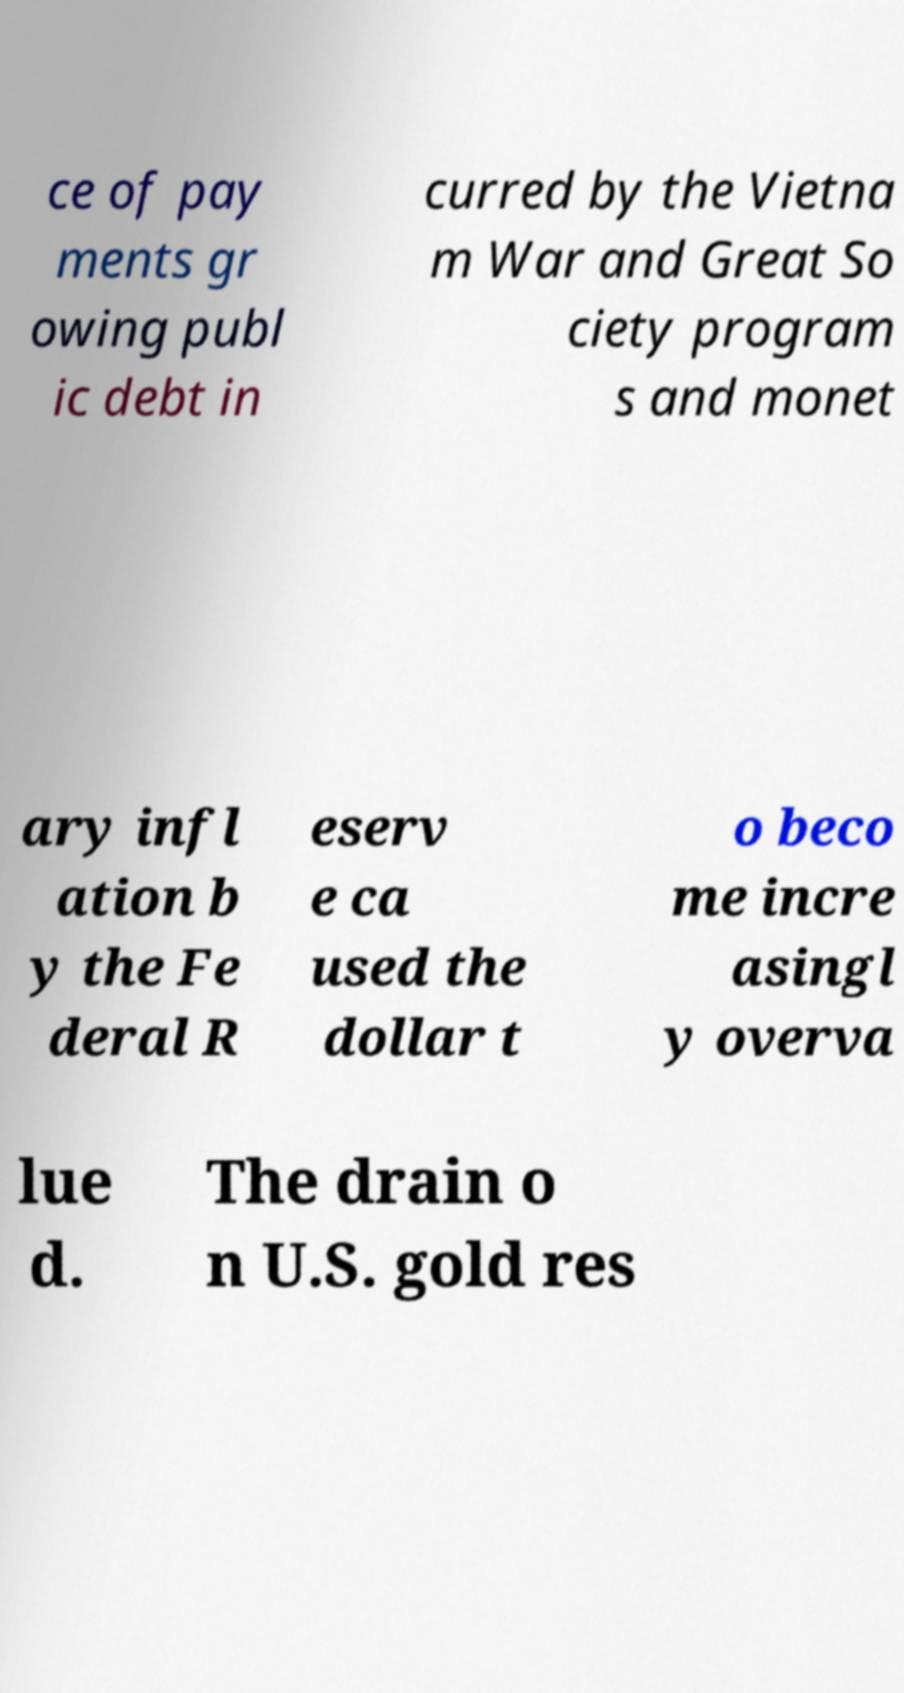I need the written content from this picture converted into text. Can you do that? ce of pay ments gr owing publ ic debt in curred by the Vietna m War and Great So ciety program s and monet ary infl ation b y the Fe deral R eserv e ca used the dollar t o beco me incre asingl y overva lue d. The drain o n U.S. gold res 